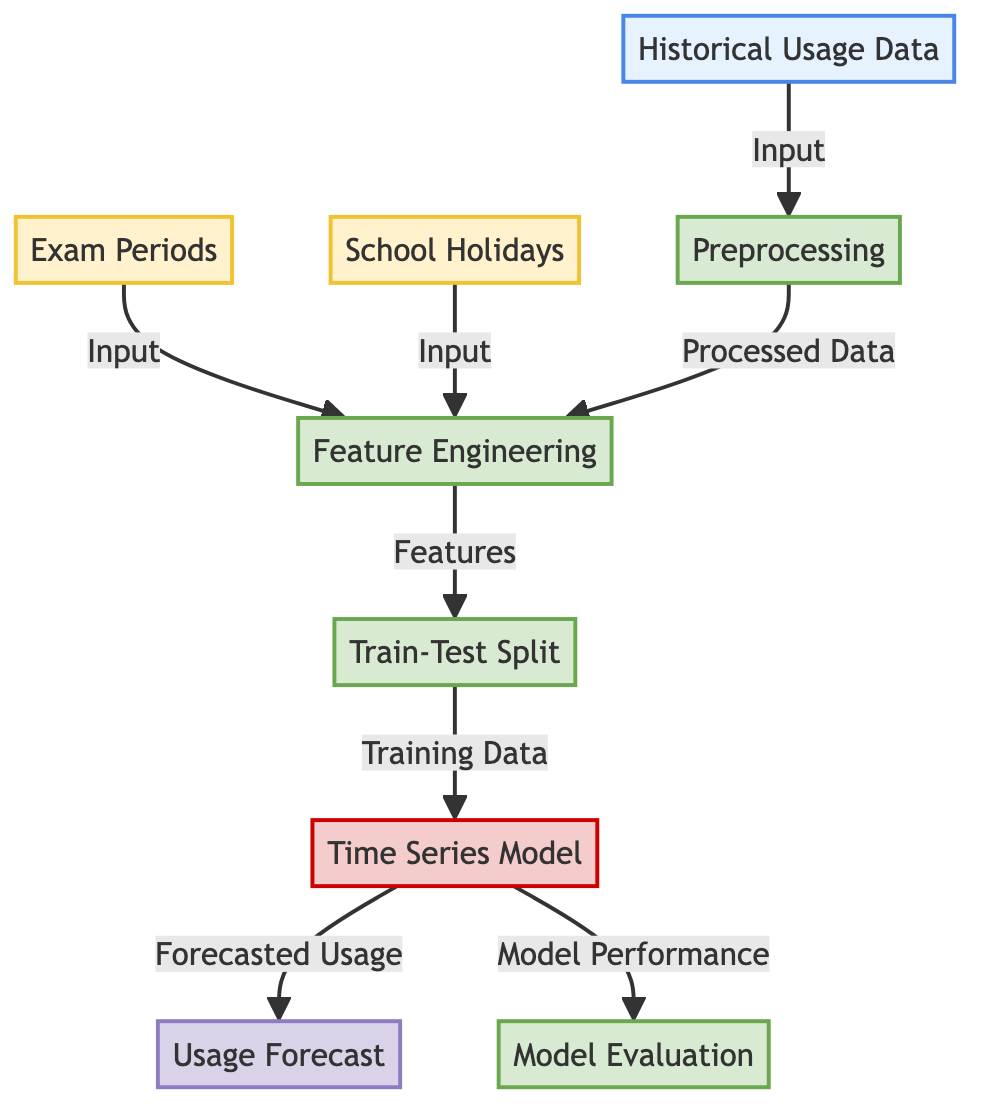What are the external factors considered in the diagram? The diagram includes external factors such as "Exam Periods" and "School Holidays." These factors are represented as nodes, indicating their role in the feature engineering process.
Answer: Exam Periods, School Holidays What type of data is used as input for preprocessing? The "Historical Usage Data" node indicates the type of data that flows into the preprocessing step. This data serves as the foundational input for further analysis.
Answer: Historical Usage Data How many processes are depicted in the diagram? There are five processes shown in the diagram: Preprocessing, Feature Engineering, Train-Test Split, Time Series Model, and Model Evaluation. Counting these nodes gives a total of five distinct processes.
Answer: Five Which node produces the final output of the diagram? The "Usage Forecast" node is the final output of the diagram, as it is linked directly to the "Time Series Model," which is responsible for generating the forecast.
Answer: Usage Forecast What links the "Feature Engineering" process to the "Time Series Model"? The "Train-Test Split" process acts as a connector between "Feature Engineering" and the "Time Series Model," indicating that the features from the previous step are divided into training and testing datasets before modeling.
Answer: Train-Test Split What is the purpose of the "Model Evaluation" process? The "Model Evaluation" process assesses the performance of the "Time Series Model." It indicates the need to evaluate how well the model forecasts based on the training data and the given features.
Answer: Assess performance Which input influences the feature engineering alongside historical data? Both "Exam Periods" and "School Holidays" influence feature engineering as these external factors provide context and additional attributes for the model.
Answer: Exam Periods, School Holidays How does the preprocessing step contribute to the diagram's processes? The preprocessing step transforms the "Historical Usage Data" into a format suitable for feature extraction, making it a critical preliminary step before engineering features for modeling.
Answer: Data transformation What is the output of the model performance evaluation? While the output of the model evaluation is not explicitly stated, it implies performance metrics related to the model's accuracy and reliability in predicting usage.
Answer: Model Performance 